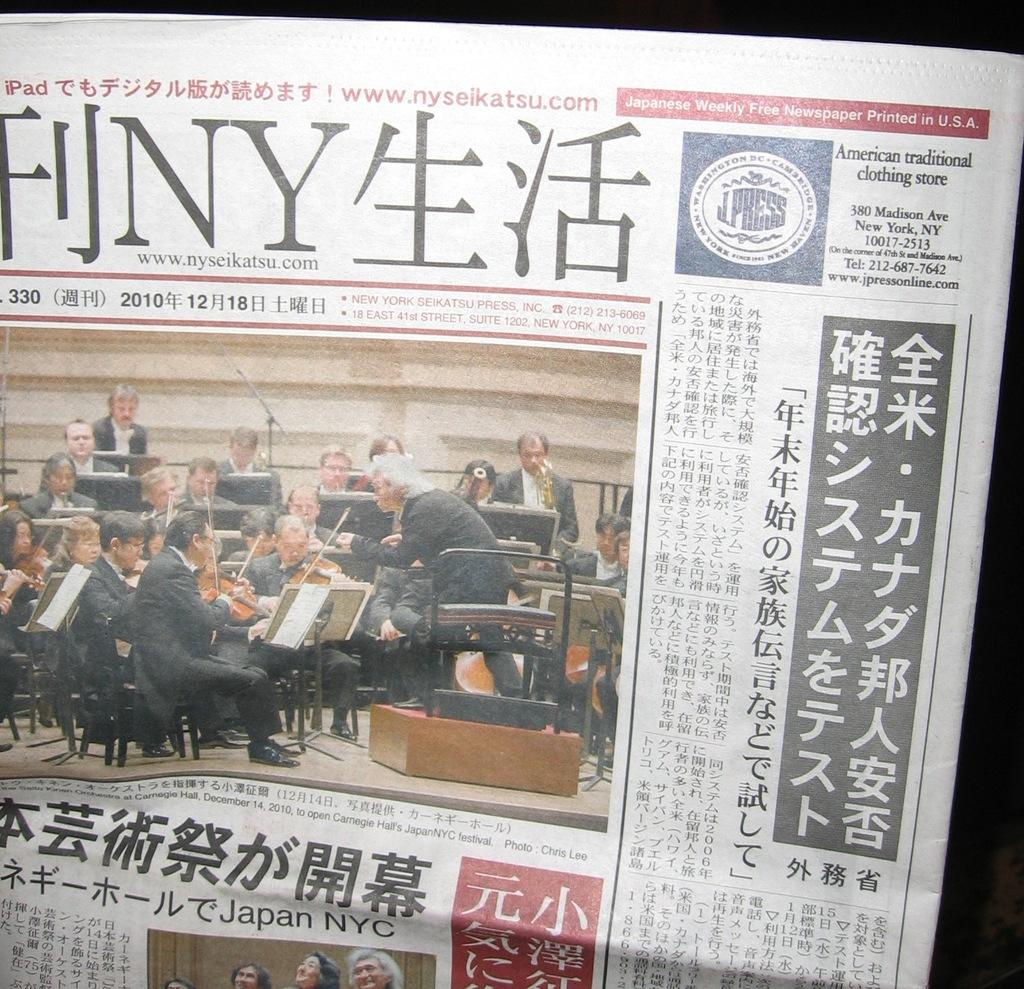<image>
Relay a brief, clear account of the picture shown. A Japanese Weekly Free Newspaper Printed in U.S.A. 